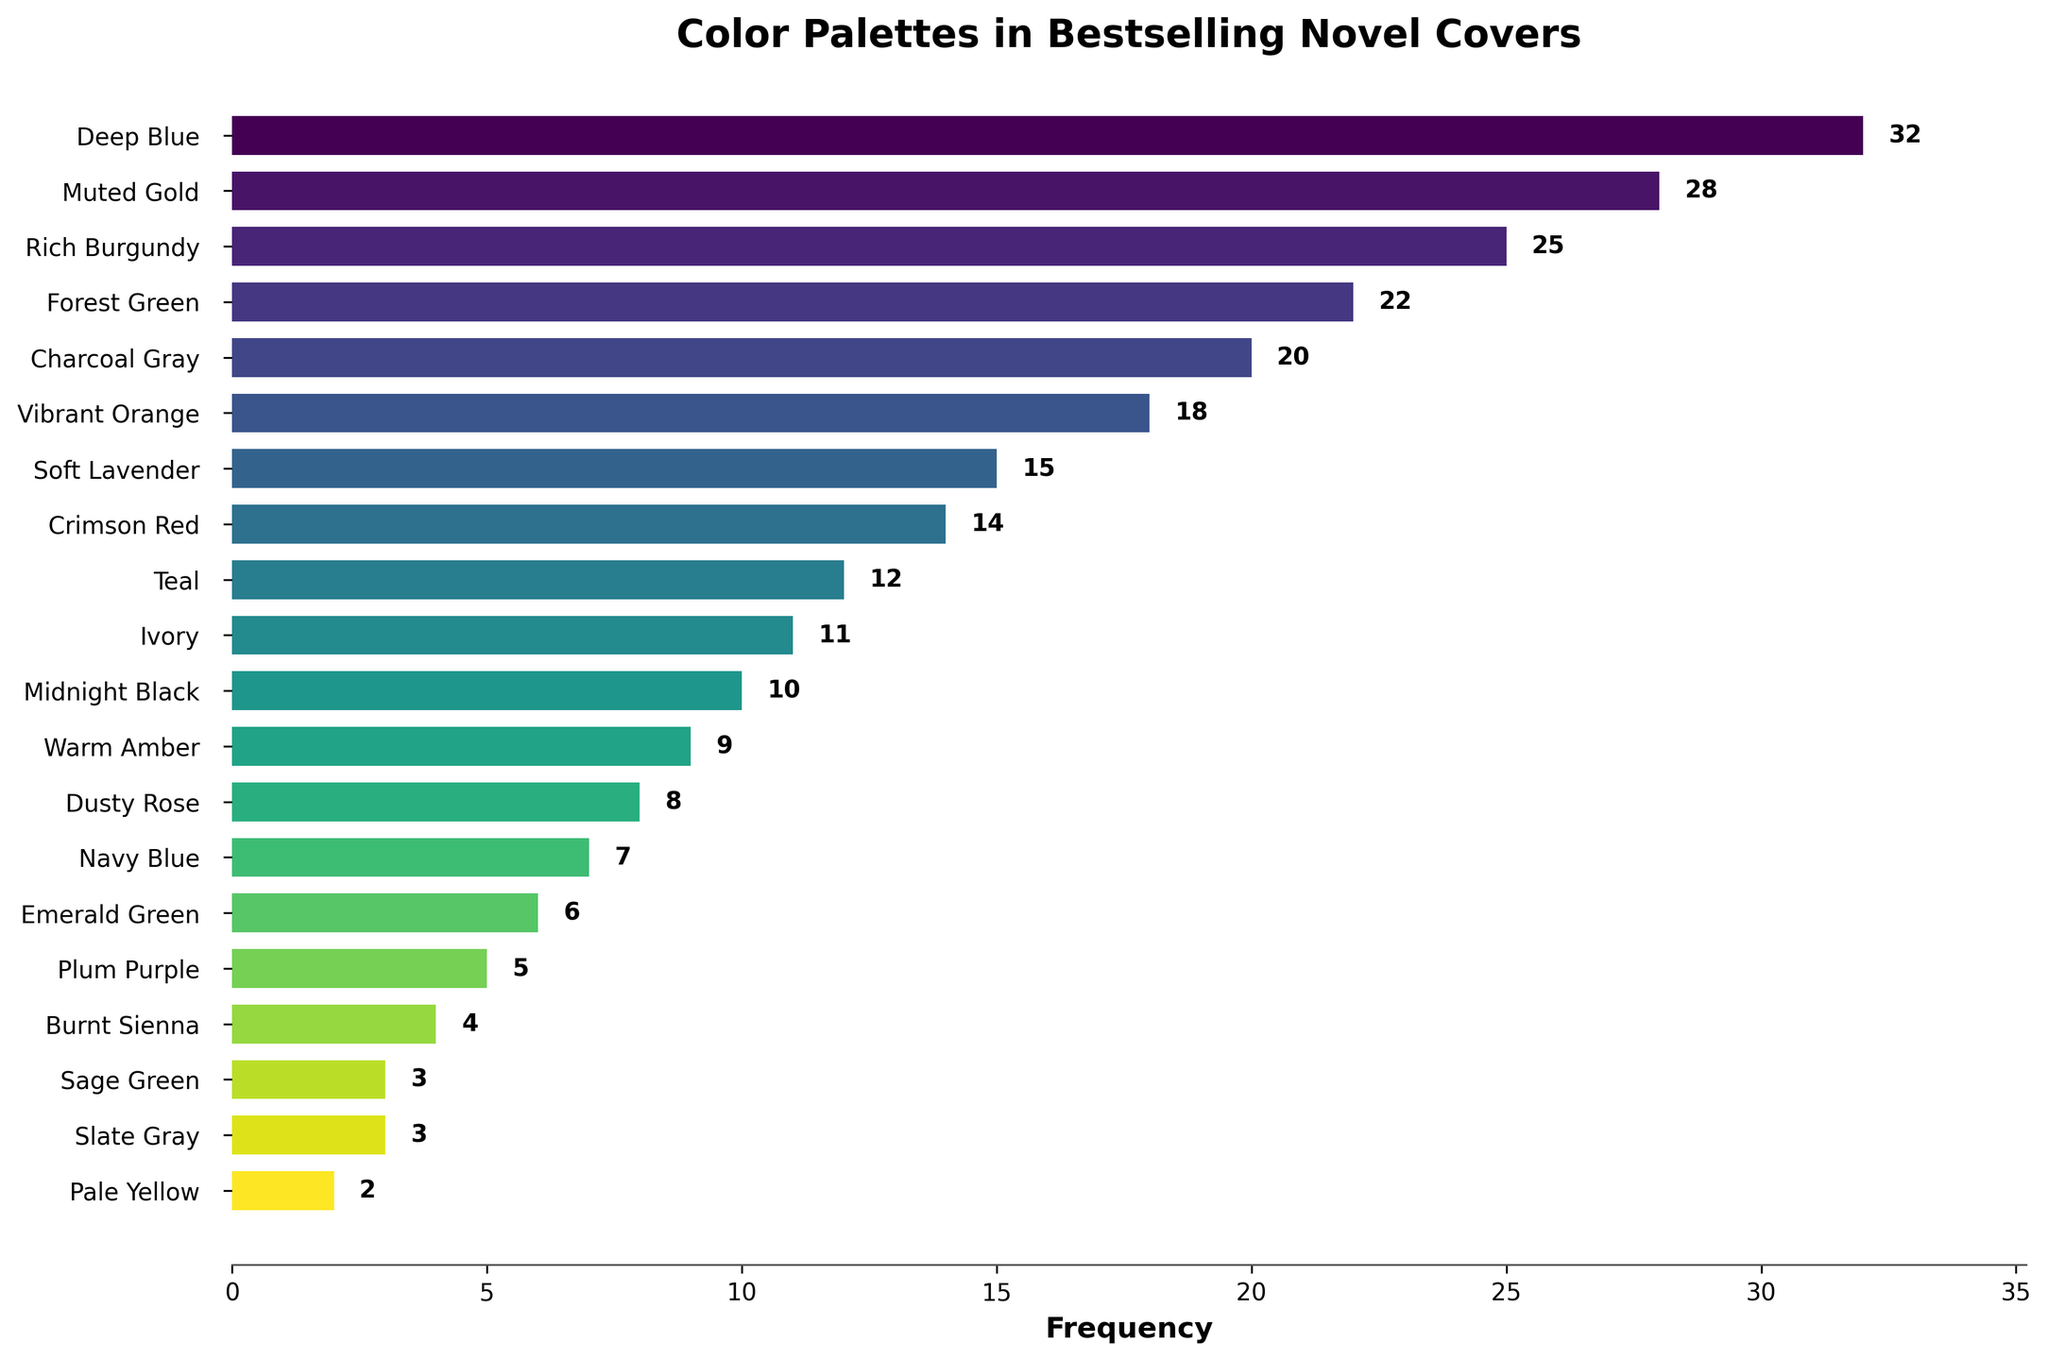Which color palette is used most frequently? The bar with the highest length corresponds to the color "Deep Blue," which has the highest frequency value
Answer: Deep Blue Which color palette is used least frequently? The bar with the shortest length corresponds to the color "Pale Yellow," which has the lowest frequency value
Answer: Pale Yellow What's the total frequency of the top three most frequent colors? The frequencies of the top three color palettes are 32 (Deep Blue), 28 (Muted Gold), and 25 (Rich Burgundy). Summing them up: 32 + 28 + 25 = 85
Answer: 85 How many colors have a frequency greater than 20? By observing the labels and their corresponding values, it is found that five color palettes have a frequency greater than 20: Deep Blue, Muted Gold, Rich Burgundy, Forest Green, and Charcoal Gray
Answer: 5 What is the median frequency of the colors? To find the median, the frequencies need to be sorted: [2, 3, 3, 4, 5, 6, 7, 8, 9, 10, 11, 12, 14, 15, 18, 20, 22, 25, 28, 32]. Since there are 20 data points, the median is the average of the 10th and 11th values: (10 + 11)/2 = 10.5
Answer: 10.5 Which colors share the same frequency? By checking the frequencies, "Slate Gray" and "Sage Green" both have a frequency of 3
Answer: Slate Gray and Sage Green Is there a difference in frequency between Forest Green and Teal? The frequency of Forest Green is 22, and the frequency of Teal is 12. The difference is 22 - 12 = 10
Answer: 10 What is the average frequency of the colors? To find the average, sum all frequencies and divide by the number of colors: (32 + 28 + 25 + 22 + 20 + 18 + 15 + 14 + 12 + 11 + 10 + 9 + 8 + 7 + 6 + 5 + 4 + 3 + 3 + 2) / 20 = 10.95
Answer: 10.95 Which color is more frequently used, Crimson Red or Burnt Sienna? The frequency of Crimson Red is 14, while Burnt Sienna is 4. Thus, Crimson Red is used more frequently
Answer: Crimson Red 